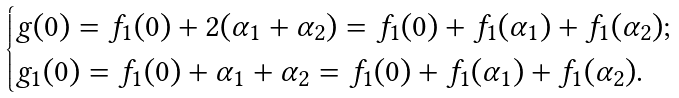<formula> <loc_0><loc_0><loc_500><loc_500>\begin{cases} g ( 0 ) = f _ { 1 } ( 0 ) + 2 ( \alpha _ { 1 } + \alpha _ { 2 } ) = f _ { 1 } ( 0 ) + f _ { 1 } ( \alpha _ { 1 } ) + f _ { 1 } ( \alpha _ { 2 } ) ; \\ g _ { 1 } ( 0 ) = f _ { 1 } ( 0 ) + \alpha _ { 1 } + \alpha _ { 2 } = f _ { 1 } ( 0 ) + f _ { 1 } ( \alpha _ { 1 } ) + f _ { 1 } ( \alpha _ { 2 } ) . \end{cases}</formula> 